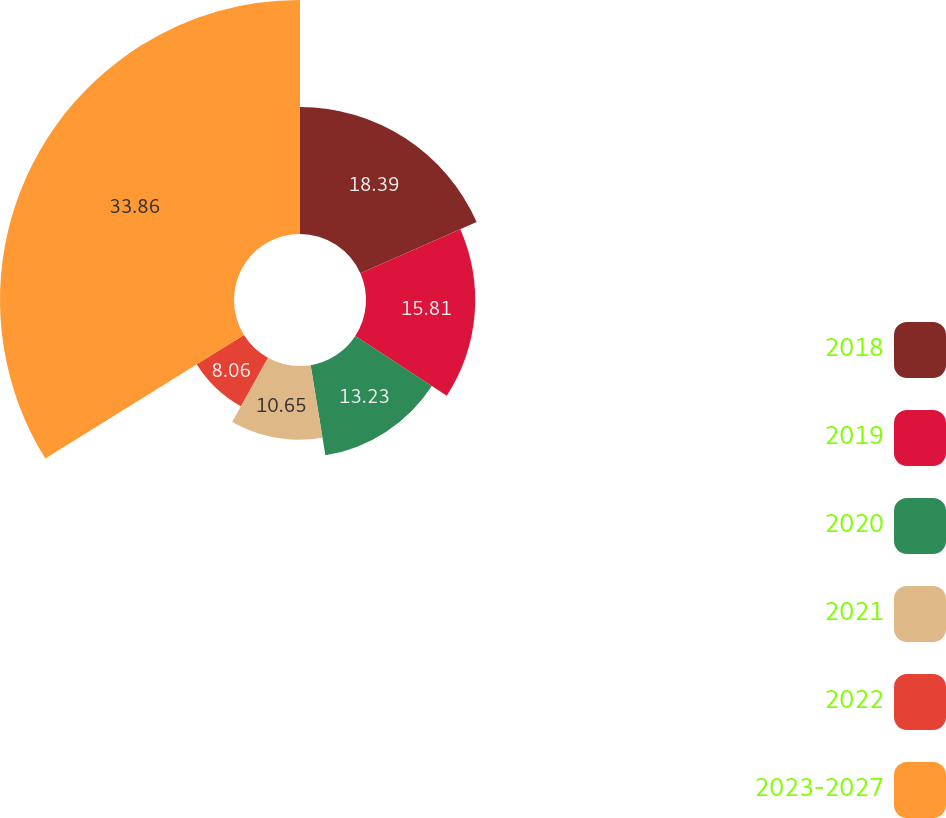Convert chart to OTSL. <chart><loc_0><loc_0><loc_500><loc_500><pie_chart><fcel>2018<fcel>2019<fcel>2020<fcel>2021<fcel>2022<fcel>2023-2027<nl><fcel>18.39%<fcel>15.81%<fcel>13.23%<fcel>10.65%<fcel>8.06%<fcel>33.87%<nl></chart> 